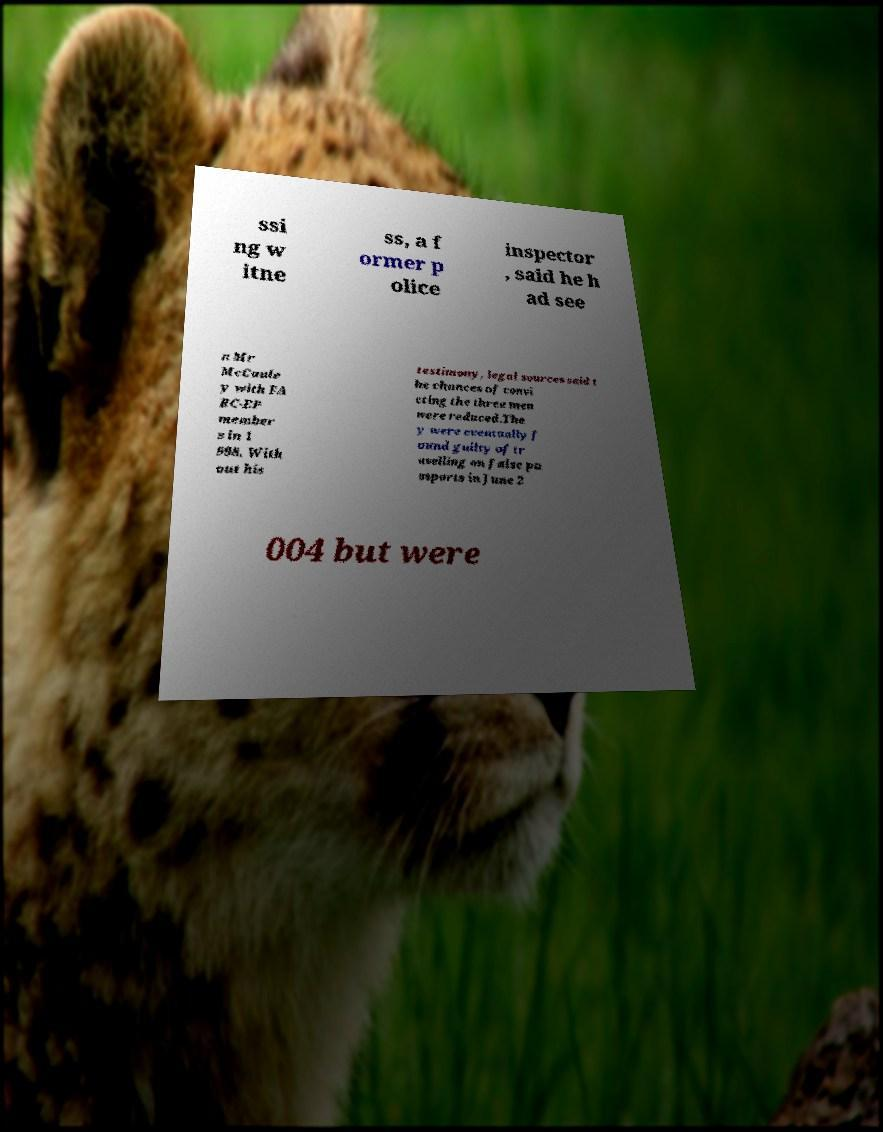I need the written content from this picture converted into text. Can you do that? ssi ng w itne ss, a f ormer p olice inspector , said he h ad see n Mr McCaule y with FA RC-EP member s in 1 998. With out his testimony, legal sources said t he chances of convi cting the three men were reduced.The y were eventually f ound guilty of tr avelling on false pa ssports in June 2 004 but were 